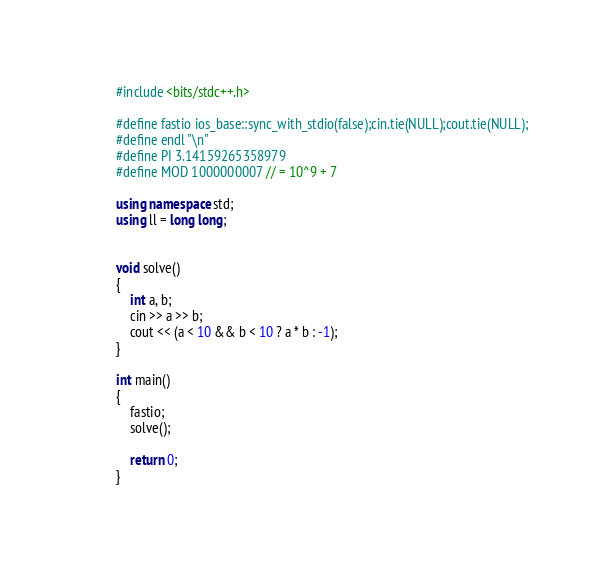<code> <loc_0><loc_0><loc_500><loc_500><_C++_>#include <bits/stdc++.h>

#define fastio ios_base::sync_with_stdio(false);cin.tie(NULL);cout.tie(NULL);
#define endl "\n"
#define PI 3.14159265358979
#define MOD 1000000007 // = 10^9 + 7

using namespace std;
using ll = long long;


void solve()
{
	int a, b;
	cin >> a >> b;
	cout << (a < 10 && b < 10 ? a * b : -1);
}

int main()
{
	fastio;
	solve();

	return 0;
}</code> 